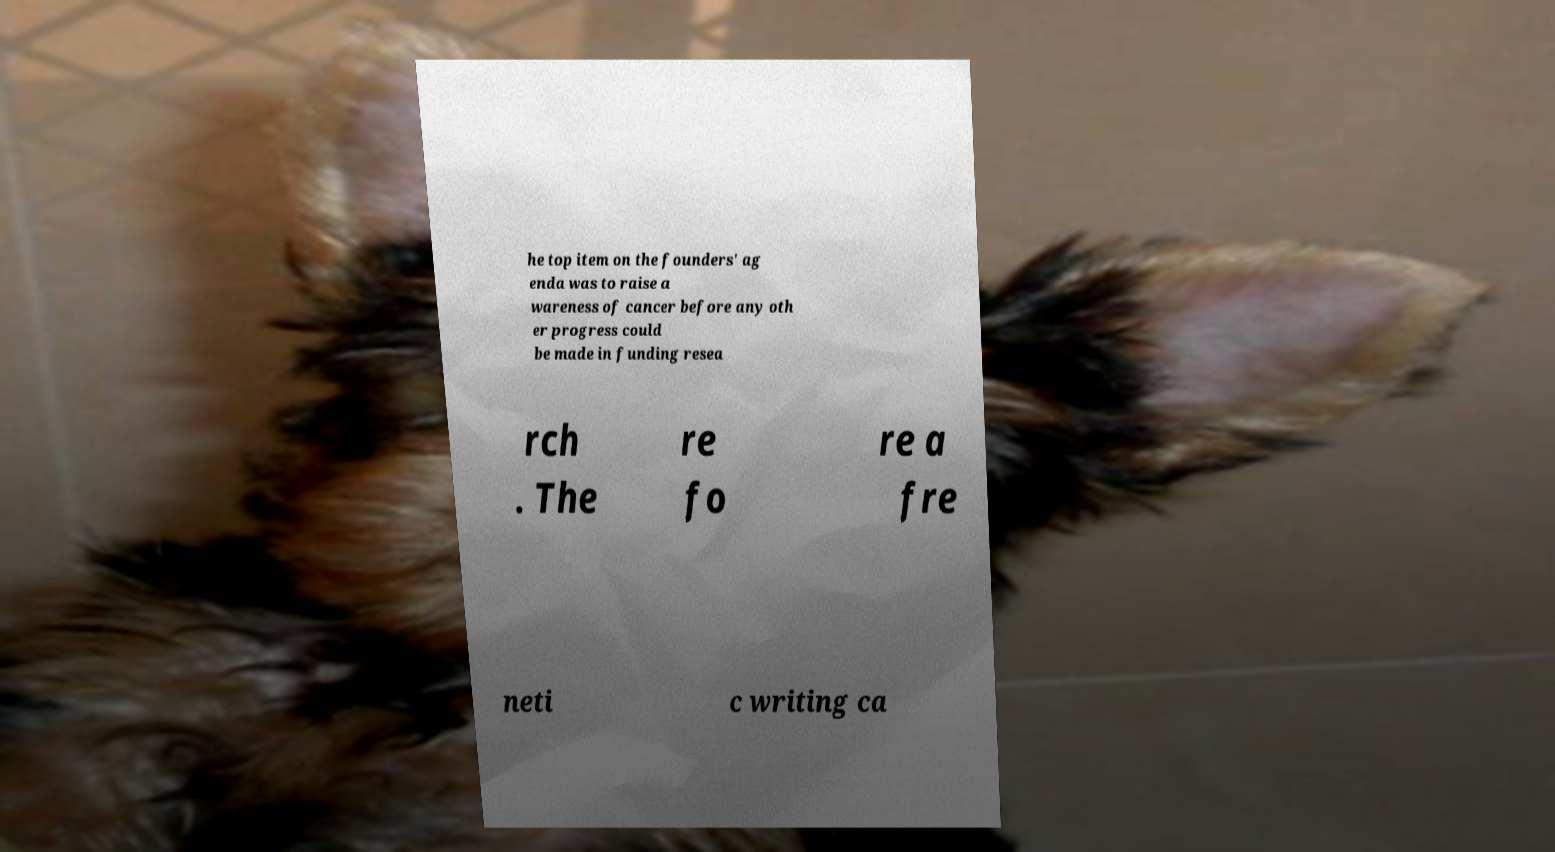Could you extract and type out the text from this image? he top item on the founders' ag enda was to raise a wareness of cancer before any oth er progress could be made in funding resea rch . The re fo re a fre neti c writing ca 